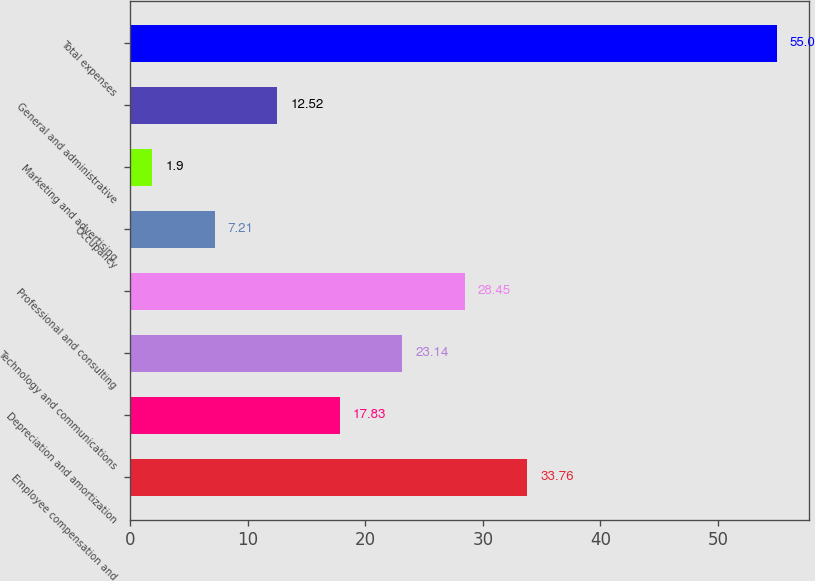Convert chart to OTSL. <chart><loc_0><loc_0><loc_500><loc_500><bar_chart><fcel>Employee compensation and<fcel>Depreciation and amortization<fcel>Technology and communications<fcel>Professional and consulting<fcel>Occupancy<fcel>Marketing and advertising<fcel>General and administrative<fcel>Total expenses<nl><fcel>33.76<fcel>17.83<fcel>23.14<fcel>28.45<fcel>7.21<fcel>1.9<fcel>12.52<fcel>55<nl></chart> 